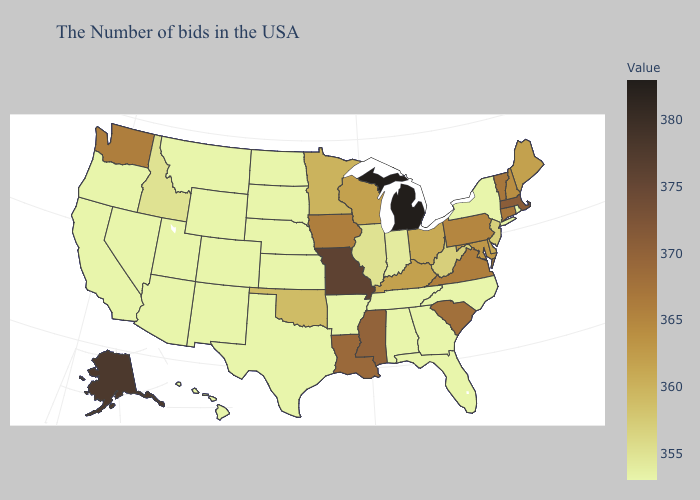Which states hav the highest value in the South?
Give a very brief answer. Mississippi. Which states have the lowest value in the Northeast?
Give a very brief answer. Rhode Island, New York. Is the legend a continuous bar?
Answer briefly. Yes. Does Idaho have the lowest value in the West?
Answer briefly. No. Among the states that border Virginia , does West Virginia have the lowest value?
Concise answer only. No. 